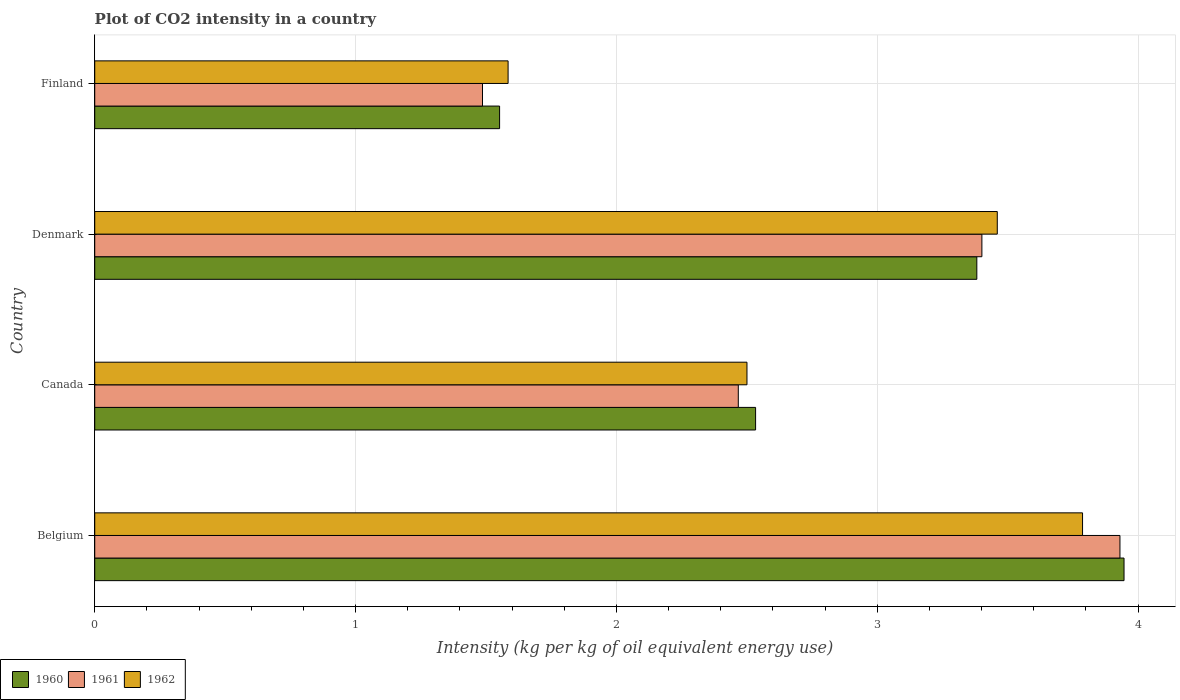Are the number of bars per tick equal to the number of legend labels?
Offer a very short reply. Yes. How many bars are there on the 2nd tick from the bottom?
Make the answer very short. 3. In how many cases, is the number of bars for a given country not equal to the number of legend labels?
Ensure brevity in your answer.  0. What is the CO2 intensity in in 1962 in Canada?
Your answer should be very brief. 2.5. Across all countries, what is the maximum CO2 intensity in in 1962?
Your answer should be compact. 3.79. Across all countries, what is the minimum CO2 intensity in in 1960?
Provide a short and direct response. 1.55. In which country was the CO2 intensity in in 1961 minimum?
Provide a short and direct response. Finland. What is the total CO2 intensity in in 1961 in the graph?
Your response must be concise. 11.28. What is the difference between the CO2 intensity in in 1962 in Canada and that in Finland?
Give a very brief answer. 0.92. What is the difference between the CO2 intensity in in 1962 in Canada and the CO2 intensity in in 1961 in Belgium?
Keep it short and to the point. -1.43. What is the average CO2 intensity in in 1961 per country?
Make the answer very short. 2.82. What is the difference between the CO2 intensity in in 1960 and CO2 intensity in in 1962 in Denmark?
Offer a terse response. -0.08. What is the ratio of the CO2 intensity in in 1961 in Denmark to that in Finland?
Keep it short and to the point. 2.29. Is the difference between the CO2 intensity in in 1960 in Denmark and Finland greater than the difference between the CO2 intensity in in 1962 in Denmark and Finland?
Your answer should be compact. No. What is the difference between the highest and the second highest CO2 intensity in in 1961?
Make the answer very short. 0.53. What is the difference between the highest and the lowest CO2 intensity in in 1960?
Your answer should be compact. 2.39. In how many countries, is the CO2 intensity in in 1962 greater than the average CO2 intensity in in 1962 taken over all countries?
Offer a very short reply. 2. Is the sum of the CO2 intensity in in 1962 in Belgium and Finland greater than the maximum CO2 intensity in in 1961 across all countries?
Provide a succinct answer. Yes. What does the 3rd bar from the top in Belgium represents?
Keep it short and to the point. 1960. Is it the case that in every country, the sum of the CO2 intensity in in 1960 and CO2 intensity in in 1962 is greater than the CO2 intensity in in 1961?
Provide a succinct answer. Yes. Are all the bars in the graph horizontal?
Offer a very short reply. Yes. What is the difference between two consecutive major ticks on the X-axis?
Your answer should be very brief. 1. Are the values on the major ticks of X-axis written in scientific E-notation?
Offer a very short reply. No. Does the graph contain grids?
Ensure brevity in your answer.  Yes. What is the title of the graph?
Your answer should be compact. Plot of CO2 intensity in a country. Does "1961" appear as one of the legend labels in the graph?
Your answer should be compact. Yes. What is the label or title of the X-axis?
Your response must be concise. Intensity (kg per kg of oil equivalent energy use). What is the label or title of the Y-axis?
Make the answer very short. Country. What is the Intensity (kg per kg of oil equivalent energy use) of 1960 in Belgium?
Your response must be concise. 3.95. What is the Intensity (kg per kg of oil equivalent energy use) in 1961 in Belgium?
Give a very brief answer. 3.93. What is the Intensity (kg per kg of oil equivalent energy use) in 1962 in Belgium?
Your response must be concise. 3.79. What is the Intensity (kg per kg of oil equivalent energy use) in 1960 in Canada?
Give a very brief answer. 2.53. What is the Intensity (kg per kg of oil equivalent energy use) in 1961 in Canada?
Provide a short and direct response. 2.47. What is the Intensity (kg per kg of oil equivalent energy use) of 1962 in Canada?
Make the answer very short. 2.5. What is the Intensity (kg per kg of oil equivalent energy use) of 1960 in Denmark?
Your response must be concise. 3.38. What is the Intensity (kg per kg of oil equivalent energy use) of 1961 in Denmark?
Keep it short and to the point. 3.4. What is the Intensity (kg per kg of oil equivalent energy use) of 1962 in Denmark?
Offer a very short reply. 3.46. What is the Intensity (kg per kg of oil equivalent energy use) of 1960 in Finland?
Your answer should be compact. 1.55. What is the Intensity (kg per kg of oil equivalent energy use) of 1961 in Finland?
Keep it short and to the point. 1.49. What is the Intensity (kg per kg of oil equivalent energy use) in 1962 in Finland?
Your answer should be very brief. 1.58. Across all countries, what is the maximum Intensity (kg per kg of oil equivalent energy use) of 1960?
Offer a terse response. 3.95. Across all countries, what is the maximum Intensity (kg per kg of oil equivalent energy use) of 1961?
Ensure brevity in your answer.  3.93. Across all countries, what is the maximum Intensity (kg per kg of oil equivalent energy use) in 1962?
Provide a succinct answer. 3.79. Across all countries, what is the minimum Intensity (kg per kg of oil equivalent energy use) of 1960?
Make the answer very short. 1.55. Across all countries, what is the minimum Intensity (kg per kg of oil equivalent energy use) in 1961?
Offer a very short reply. 1.49. Across all countries, what is the minimum Intensity (kg per kg of oil equivalent energy use) in 1962?
Offer a very short reply. 1.58. What is the total Intensity (kg per kg of oil equivalent energy use) of 1960 in the graph?
Ensure brevity in your answer.  11.41. What is the total Intensity (kg per kg of oil equivalent energy use) of 1961 in the graph?
Give a very brief answer. 11.28. What is the total Intensity (kg per kg of oil equivalent energy use) in 1962 in the graph?
Keep it short and to the point. 11.33. What is the difference between the Intensity (kg per kg of oil equivalent energy use) of 1960 in Belgium and that in Canada?
Offer a terse response. 1.41. What is the difference between the Intensity (kg per kg of oil equivalent energy use) of 1961 in Belgium and that in Canada?
Provide a succinct answer. 1.46. What is the difference between the Intensity (kg per kg of oil equivalent energy use) in 1962 in Belgium and that in Canada?
Provide a short and direct response. 1.29. What is the difference between the Intensity (kg per kg of oil equivalent energy use) of 1960 in Belgium and that in Denmark?
Your answer should be compact. 0.56. What is the difference between the Intensity (kg per kg of oil equivalent energy use) of 1961 in Belgium and that in Denmark?
Your response must be concise. 0.53. What is the difference between the Intensity (kg per kg of oil equivalent energy use) in 1962 in Belgium and that in Denmark?
Your answer should be compact. 0.33. What is the difference between the Intensity (kg per kg of oil equivalent energy use) of 1960 in Belgium and that in Finland?
Your response must be concise. 2.39. What is the difference between the Intensity (kg per kg of oil equivalent energy use) in 1961 in Belgium and that in Finland?
Offer a terse response. 2.44. What is the difference between the Intensity (kg per kg of oil equivalent energy use) in 1962 in Belgium and that in Finland?
Provide a short and direct response. 2.2. What is the difference between the Intensity (kg per kg of oil equivalent energy use) of 1960 in Canada and that in Denmark?
Your answer should be very brief. -0.85. What is the difference between the Intensity (kg per kg of oil equivalent energy use) in 1961 in Canada and that in Denmark?
Offer a very short reply. -0.93. What is the difference between the Intensity (kg per kg of oil equivalent energy use) in 1962 in Canada and that in Denmark?
Ensure brevity in your answer.  -0.96. What is the difference between the Intensity (kg per kg of oil equivalent energy use) in 1960 in Canada and that in Finland?
Provide a succinct answer. 0.98. What is the difference between the Intensity (kg per kg of oil equivalent energy use) in 1961 in Canada and that in Finland?
Keep it short and to the point. 0.98. What is the difference between the Intensity (kg per kg of oil equivalent energy use) in 1962 in Canada and that in Finland?
Offer a terse response. 0.92. What is the difference between the Intensity (kg per kg of oil equivalent energy use) of 1960 in Denmark and that in Finland?
Your answer should be compact. 1.83. What is the difference between the Intensity (kg per kg of oil equivalent energy use) in 1961 in Denmark and that in Finland?
Your answer should be compact. 1.91. What is the difference between the Intensity (kg per kg of oil equivalent energy use) in 1962 in Denmark and that in Finland?
Provide a short and direct response. 1.88. What is the difference between the Intensity (kg per kg of oil equivalent energy use) of 1960 in Belgium and the Intensity (kg per kg of oil equivalent energy use) of 1961 in Canada?
Your answer should be compact. 1.48. What is the difference between the Intensity (kg per kg of oil equivalent energy use) of 1960 in Belgium and the Intensity (kg per kg of oil equivalent energy use) of 1962 in Canada?
Provide a succinct answer. 1.45. What is the difference between the Intensity (kg per kg of oil equivalent energy use) of 1961 in Belgium and the Intensity (kg per kg of oil equivalent energy use) of 1962 in Canada?
Ensure brevity in your answer.  1.43. What is the difference between the Intensity (kg per kg of oil equivalent energy use) in 1960 in Belgium and the Intensity (kg per kg of oil equivalent energy use) in 1961 in Denmark?
Offer a terse response. 0.54. What is the difference between the Intensity (kg per kg of oil equivalent energy use) in 1960 in Belgium and the Intensity (kg per kg of oil equivalent energy use) in 1962 in Denmark?
Ensure brevity in your answer.  0.49. What is the difference between the Intensity (kg per kg of oil equivalent energy use) in 1961 in Belgium and the Intensity (kg per kg of oil equivalent energy use) in 1962 in Denmark?
Offer a very short reply. 0.47. What is the difference between the Intensity (kg per kg of oil equivalent energy use) of 1960 in Belgium and the Intensity (kg per kg of oil equivalent energy use) of 1961 in Finland?
Give a very brief answer. 2.46. What is the difference between the Intensity (kg per kg of oil equivalent energy use) of 1960 in Belgium and the Intensity (kg per kg of oil equivalent energy use) of 1962 in Finland?
Offer a terse response. 2.36. What is the difference between the Intensity (kg per kg of oil equivalent energy use) of 1961 in Belgium and the Intensity (kg per kg of oil equivalent energy use) of 1962 in Finland?
Provide a short and direct response. 2.35. What is the difference between the Intensity (kg per kg of oil equivalent energy use) in 1960 in Canada and the Intensity (kg per kg of oil equivalent energy use) in 1961 in Denmark?
Ensure brevity in your answer.  -0.87. What is the difference between the Intensity (kg per kg of oil equivalent energy use) of 1960 in Canada and the Intensity (kg per kg of oil equivalent energy use) of 1962 in Denmark?
Your answer should be compact. -0.93. What is the difference between the Intensity (kg per kg of oil equivalent energy use) in 1961 in Canada and the Intensity (kg per kg of oil equivalent energy use) in 1962 in Denmark?
Ensure brevity in your answer.  -0.99. What is the difference between the Intensity (kg per kg of oil equivalent energy use) in 1960 in Canada and the Intensity (kg per kg of oil equivalent energy use) in 1961 in Finland?
Keep it short and to the point. 1.05. What is the difference between the Intensity (kg per kg of oil equivalent energy use) in 1960 in Canada and the Intensity (kg per kg of oil equivalent energy use) in 1962 in Finland?
Offer a very short reply. 0.95. What is the difference between the Intensity (kg per kg of oil equivalent energy use) in 1961 in Canada and the Intensity (kg per kg of oil equivalent energy use) in 1962 in Finland?
Provide a short and direct response. 0.88. What is the difference between the Intensity (kg per kg of oil equivalent energy use) of 1960 in Denmark and the Intensity (kg per kg of oil equivalent energy use) of 1961 in Finland?
Give a very brief answer. 1.9. What is the difference between the Intensity (kg per kg of oil equivalent energy use) in 1960 in Denmark and the Intensity (kg per kg of oil equivalent energy use) in 1962 in Finland?
Your response must be concise. 1.8. What is the difference between the Intensity (kg per kg of oil equivalent energy use) of 1961 in Denmark and the Intensity (kg per kg of oil equivalent energy use) of 1962 in Finland?
Your answer should be very brief. 1.82. What is the average Intensity (kg per kg of oil equivalent energy use) in 1960 per country?
Provide a short and direct response. 2.85. What is the average Intensity (kg per kg of oil equivalent energy use) of 1961 per country?
Keep it short and to the point. 2.82. What is the average Intensity (kg per kg of oil equivalent energy use) of 1962 per country?
Offer a very short reply. 2.83. What is the difference between the Intensity (kg per kg of oil equivalent energy use) of 1960 and Intensity (kg per kg of oil equivalent energy use) of 1961 in Belgium?
Make the answer very short. 0.02. What is the difference between the Intensity (kg per kg of oil equivalent energy use) in 1960 and Intensity (kg per kg of oil equivalent energy use) in 1962 in Belgium?
Your answer should be very brief. 0.16. What is the difference between the Intensity (kg per kg of oil equivalent energy use) of 1961 and Intensity (kg per kg of oil equivalent energy use) of 1962 in Belgium?
Your response must be concise. 0.14. What is the difference between the Intensity (kg per kg of oil equivalent energy use) of 1960 and Intensity (kg per kg of oil equivalent energy use) of 1961 in Canada?
Offer a very short reply. 0.07. What is the difference between the Intensity (kg per kg of oil equivalent energy use) of 1960 and Intensity (kg per kg of oil equivalent energy use) of 1962 in Canada?
Offer a very short reply. 0.03. What is the difference between the Intensity (kg per kg of oil equivalent energy use) of 1961 and Intensity (kg per kg of oil equivalent energy use) of 1962 in Canada?
Ensure brevity in your answer.  -0.03. What is the difference between the Intensity (kg per kg of oil equivalent energy use) of 1960 and Intensity (kg per kg of oil equivalent energy use) of 1961 in Denmark?
Offer a terse response. -0.02. What is the difference between the Intensity (kg per kg of oil equivalent energy use) of 1960 and Intensity (kg per kg of oil equivalent energy use) of 1962 in Denmark?
Your response must be concise. -0.08. What is the difference between the Intensity (kg per kg of oil equivalent energy use) of 1961 and Intensity (kg per kg of oil equivalent energy use) of 1962 in Denmark?
Make the answer very short. -0.06. What is the difference between the Intensity (kg per kg of oil equivalent energy use) of 1960 and Intensity (kg per kg of oil equivalent energy use) of 1961 in Finland?
Offer a very short reply. 0.07. What is the difference between the Intensity (kg per kg of oil equivalent energy use) in 1960 and Intensity (kg per kg of oil equivalent energy use) in 1962 in Finland?
Provide a succinct answer. -0.03. What is the difference between the Intensity (kg per kg of oil equivalent energy use) in 1961 and Intensity (kg per kg of oil equivalent energy use) in 1962 in Finland?
Give a very brief answer. -0.1. What is the ratio of the Intensity (kg per kg of oil equivalent energy use) in 1960 in Belgium to that in Canada?
Give a very brief answer. 1.56. What is the ratio of the Intensity (kg per kg of oil equivalent energy use) of 1961 in Belgium to that in Canada?
Keep it short and to the point. 1.59. What is the ratio of the Intensity (kg per kg of oil equivalent energy use) in 1962 in Belgium to that in Canada?
Offer a terse response. 1.51. What is the ratio of the Intensity (kg per kg of oil equivalent energy use) of 1960 in Belgium to that in Denmark?
Offer a very short reply. 1.17. What is the ratio of the Intensity (kg per kg of oil equivalent energy use) in 1961 in Belgium to that in Denmark?
Offer a very short reply. 1.16. What is the ratio of the Intensity (kg per kg of oil equivalent energy use) of 1962 in Belgium to that in Denmark?
Your answer should be very brief. 1.09. What is the ratio of the Intensity (kg per kg of oil equivalent energy use) of 1960 in Belgium to that in Finland?
Offer a very short reply. 2.54. What is the ratio of the Intensity (kg per kg of oil equivalent energy use) of 1961 in Belgium to that in Finland?
Make the answer very short. 2.64. What is the ratio of the Intensity (kg per kg of oil equivalent energy use) of 1962 in Belgium to that in Finland?
Offer a terse response. 2.39. What is the ratio of the Intensity (kg per kg of oil equivalent energy use) of 1960 in Canada to that in Denmark?
Make the answer very short. 0.75. What is the ratio of the Intensity (kg per kg of oil equivalent energy use) of 1961 in Canada to that in Denmark?
Offer a very short reply. 0.73. What is the ratio of the Intensity (kg per kg of oil equivalent energy use) of 1962 in Canada to that in Denmark?
Give a very brief answer. 0.72. What is the ratio of the Intensity (kg per kg of oil equivalent energy use) in 1960 in Canada to that in Finland?
Ensure brevity in your answer.  1.63. What is the ratio of the Intensity (kg per kg of oil equivalent energy use) in 1961 in Canada to that in Finland?
Keep it short and to the point. 1.66. What is the ratio of the Intensity (kg per kg of oil equivalent energy use) in 1962 in Canada to that in Finland?
Offer a very short reply. 1.58. What is the ratio of the Intensity (kg per kg of oil equivalent energy use) of 1960 in Denmark to that in Finland?
Your answer should be very brief. 2.18. What is the ratio of the Intensity (kg per kg of oil equivalent energy use) in 1961 in Denmark to that in Finland?
Offer a terse response. 2.29. What is the ratio of the Intensity (kg per kg of oil equivalent energy use) in 1962 in Denmark to that in Finland?
Offer a terse response. 2.18. What is the difference between the highest and the second highest Intensity (kg per kg of oil equivalent energy use) in 1960?
Give a very brief answer. 0.56. What is the difference between the highest and the second highest Intensity (kg per kg of oil equivalent energy use) of 1961?
Ensure brevity in your answer.  0.53. What is the difference between the highest and the second highest Intensity (kg per kg of oil equivalent energy use) of 1962?
Your response must be concise. 0.33. What is the difference between the highest and the lowest Intensity (kg per kg of oil equivalent energy use) of 1960?
Provide a short and direct response. 2.39. What is the difference between the highest and the lowest Intensity (kg per kg of oil equivalent energy use) in 1961?
Your answer should be very brief. 2.44. What is the difference between the highest and the lowest Intensity (kg per kg of oil equivalent energy use) of 1962?
Provide a succinct answer. 2.2. 